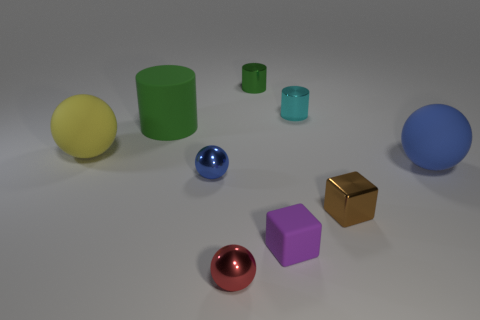Is the color of the metal cylinder behind the tiny cyan thing the same as the big cylinder?
Ensure brevity in your answer.  Yes. Are there any large objects that are right of the small green metal thing on the left side of the large blue rubber thing?
Offer a terse response. Yes. There is a big thing that is both in front of the large green object and behind the big blue matte ball; what is its material?
Offer a very short reply. Rubber. What is the shape of the blue thing that is the same material as the cyan cylinder?
Offer a terse response. Sphere. Are the blue ball that is on the left side of the big blue thing and the brown cube made of the same material?
Give a very brief answer. Yes. What is the material of the large sphere that is on the left side of the tiny purple object?
Keep it short and to the point. Rubber. There is a shiny ball behind the small ball in front of the small blue ball; what size is it?
Your response must be concise. Small. How many green things are the same size as the purple matte object?
Your answer should be very brief. 1. There is a metallic thing that is on the left side of the red thing; does it have the same color as the matte object that is on the right side of the small brown cube?
Offer a very short reply. Yes. Are there any small red metal balls right of the small brown metallic cube?
Your answer should be compact. No. 